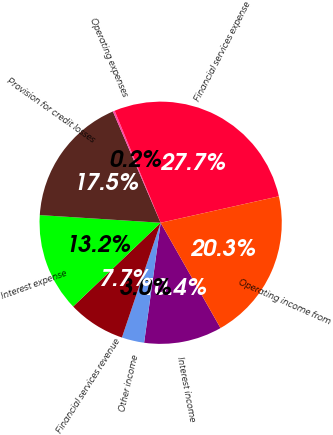Convert chart to OTSL. <chart><loc_0><loc_0><loc_500><loc_500><pie_chart><fcel>Interest income<fcel>Other income<fcel>Financial services revenue<fcel>Interest expense<fcel>Provision for credit losses<fcel>Operating expenses<fcel>Financial services expense<fcel>Operating income from<nl><fcel>10.41%<fcel>3.0%<fcel>7.67%<fcel>13.16%<fcel>17.54%<fcel>0.25%<fcel>27.7%<fcel>20.28%<nl></chart> 